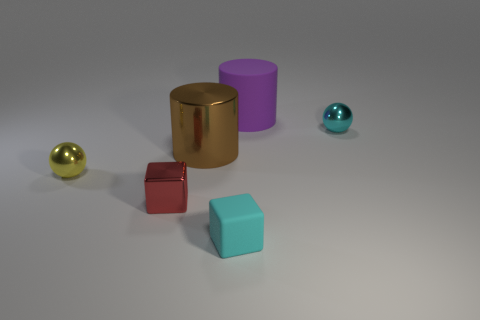Add 3 large blue rubber objects. How many objects exist? 9 Subtract all spheres. How many objects are left? 4 Add 1 cyan things. How many cyan things are left? 3 Add 6 large gray blocks. How many large gray blocks exist? 6 Subtract 0 green cylinders. How many objects are left? 6 Subtract all shiny objects. Subtract all big red matte balls. How many objects are left? 2 